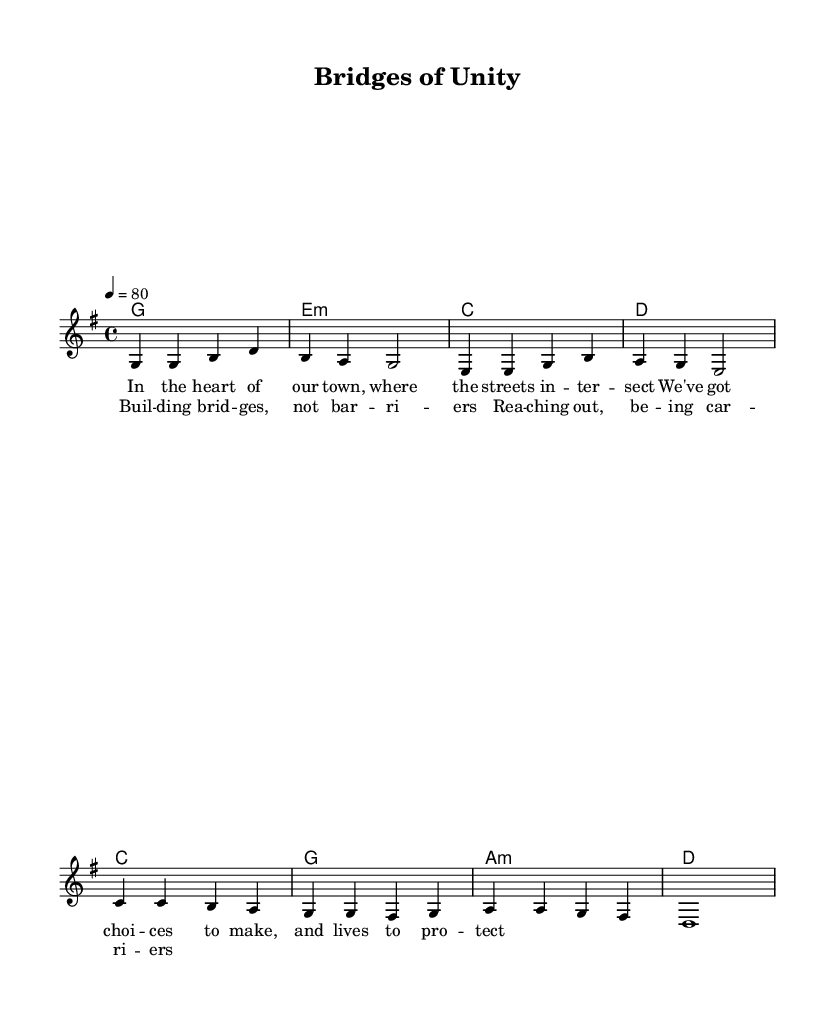What is the key signature of this music? The key signature is G major, which has one sharp (F#).
Answer: G major What is the time signature of the piece? The piece is in 4/4 time signature, which indicates four beats per measure.
Answer: 4/4 What is the tempo marking for this piece? The tempo marking indicates a speed of quarter note = 80 beats per minute.
Answer: 80 How many measures are present in the verse? The verse has a total of four measures as indicated by the way the melody is structured.
Answer: 4 What are the first two chords in the verse? The first two chords in the verse are G major and E minor, as seen at the start of the chord progression.
Answer: G major, E minor Why is this song classified as "soft rock"? This song is classified as "soft rock" due to its gentle melody, lyrical focus on social themes, and harmonic simplicity that distinguishes it from harder rock genres.
Answer: Gentle melody, social themes What is the main theme of the chorus? The main theme of the chorus revolves around unity and community engagement, as expressed through the lyrics discussing building bridges.
Answer: Unity and community engagement 